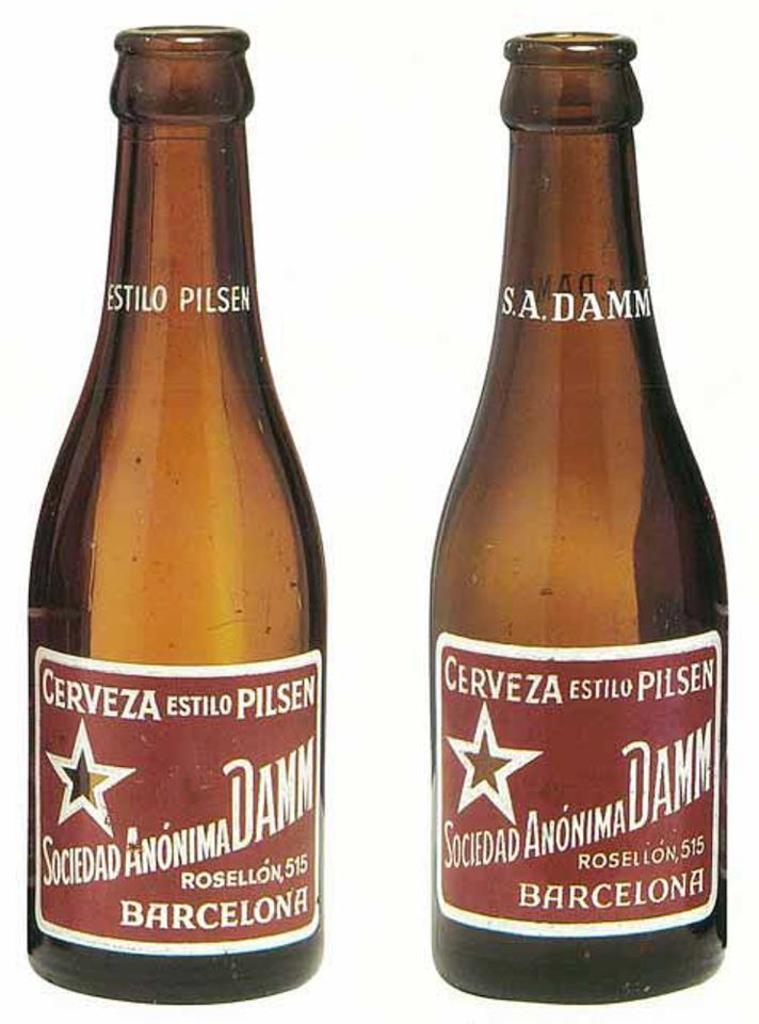What city is mentioned on the bottle?
Your answer should be compact. Barcelona. 